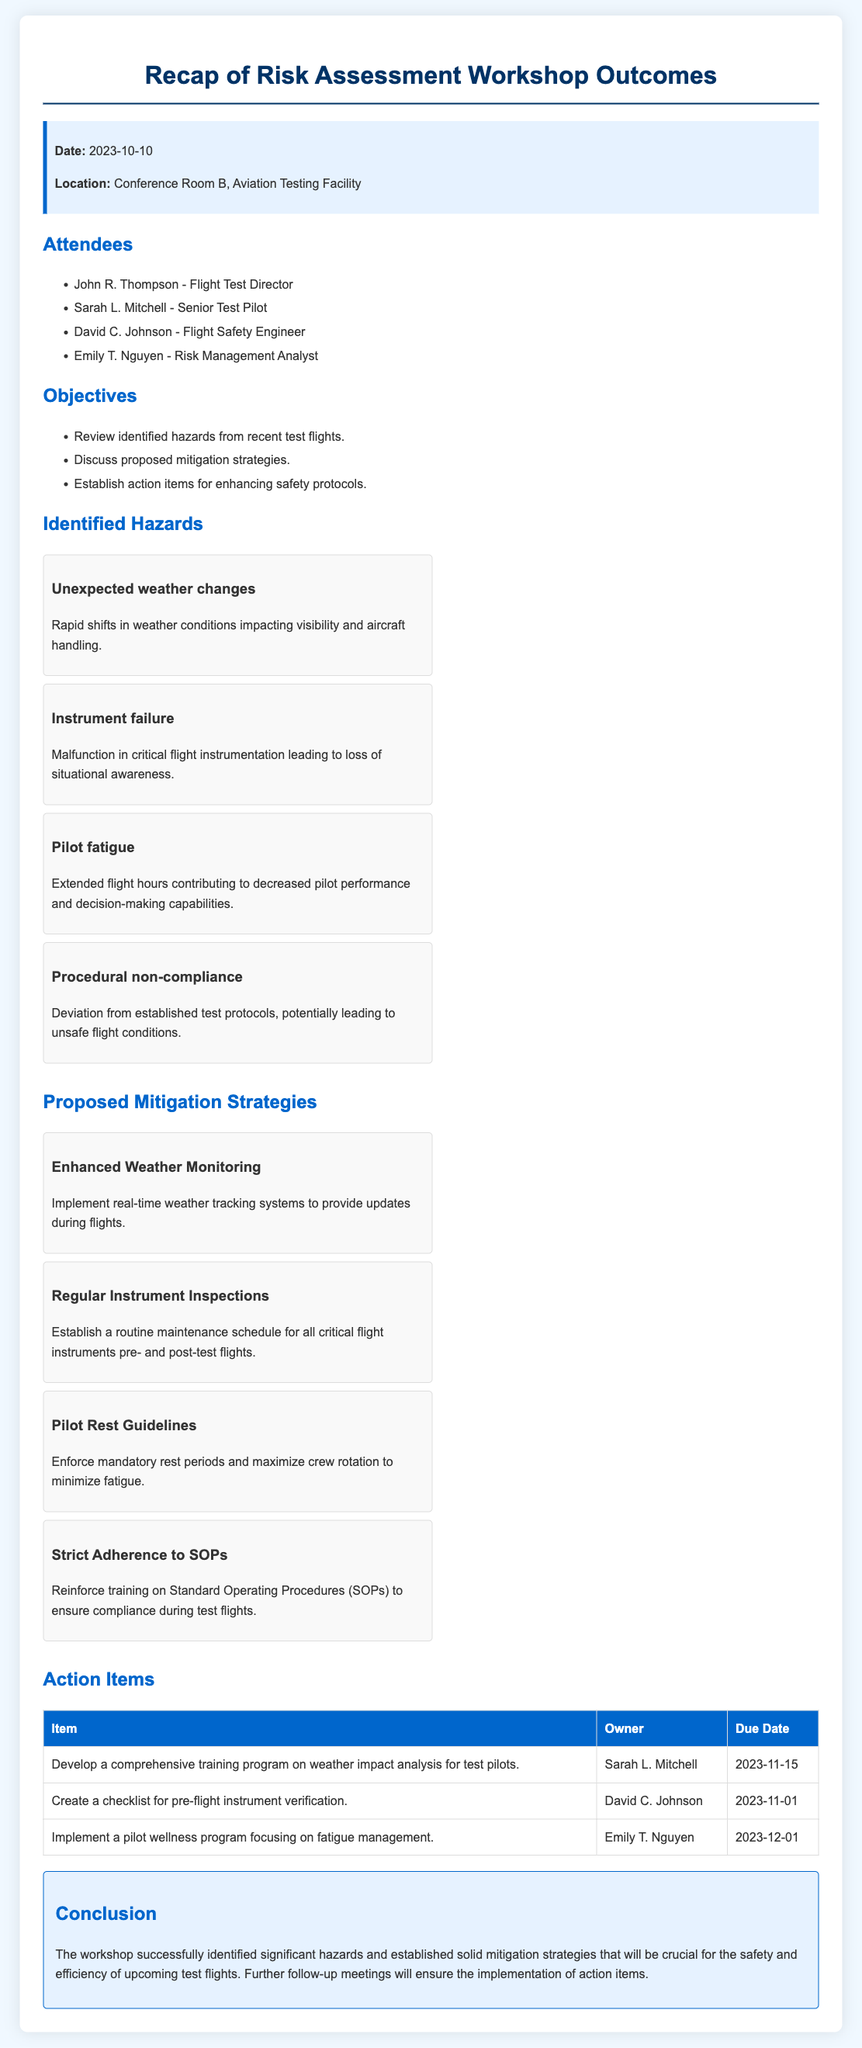What date was the workshop held? The date is mentioned in the meeting information section of the document.
Answer: 2023-10-10 Who is the Flight Test Director? This information can be found in the list of attendees.
Answer: John R. Thompson What hazard involves rapid shifts in weather? The document specifically lists this hazard under identified hazards.
Answer: Unexpected weather changes What is a proposed strategy for instrument failure? This can be found in the proposed mitigation strategies section.
Answer: Regular Instrument Inspections What action item is due on November 1st? This information is detailed in the action items table.
Answer: Create a checklist for pre-flight instrument verification How many attendees were present at the workshop? This is represented by the list of attendees provided in the document.
Answer: 4 What strategy focuses on reducing pilot fatigue? This is found in the proposed mitigation strategies section.
Answer: Pilot Rest Guidelines What is the conclusion about the workshop outcomes? The conclusion summarizes the overall results of the workshop.
Answer: Identified significant hazards and established solid mitigation strategies 